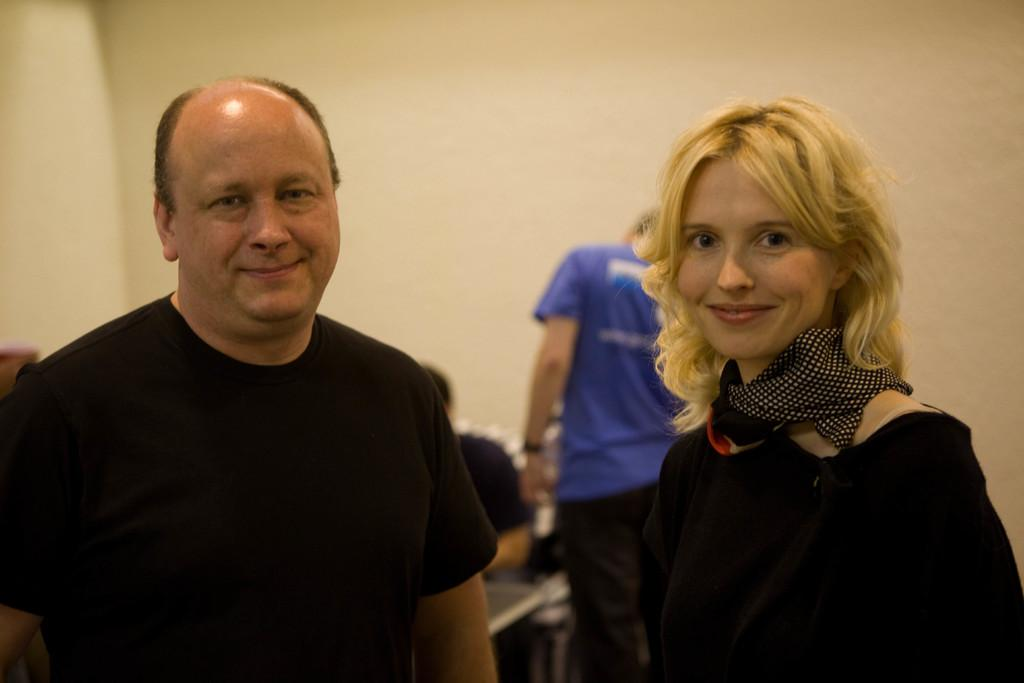How many people are present in the image? There are two people in the image. What are the two people doing in the image? The two people are standing and smiling. Can you describe the background of the image? There are people and a wall in the background of the image. What type of property can be seen in the image? There is no property visible in the image; it only features two people standing and smiling, with people and a wall in the background. How many bananas are being held by the people in the image? There are no bananas present in the image. 